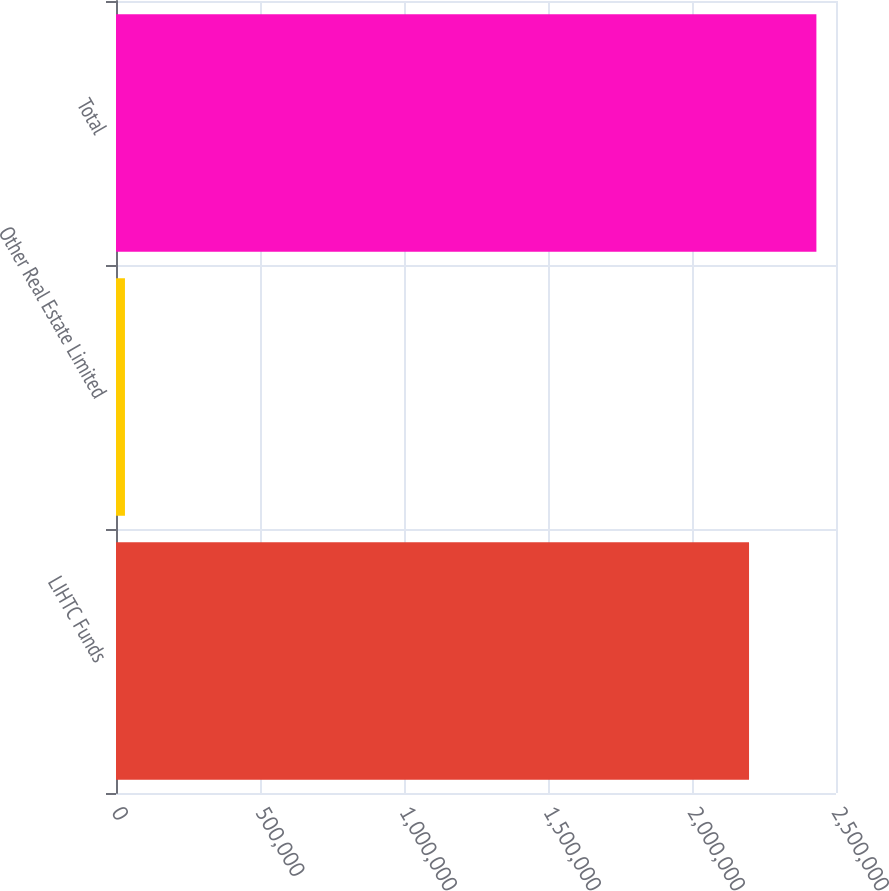Convert chart to OTSL. <chart><loc_0><loc_0><loc_500><loc_500><bar_chart><fcel>LIHTC Funds<fcel>Other Real Estate Limited<fcel>Total<nl><fcel>2.19805e+06<fcel>31107<fcel>2.43192e+06<nl></chart> 